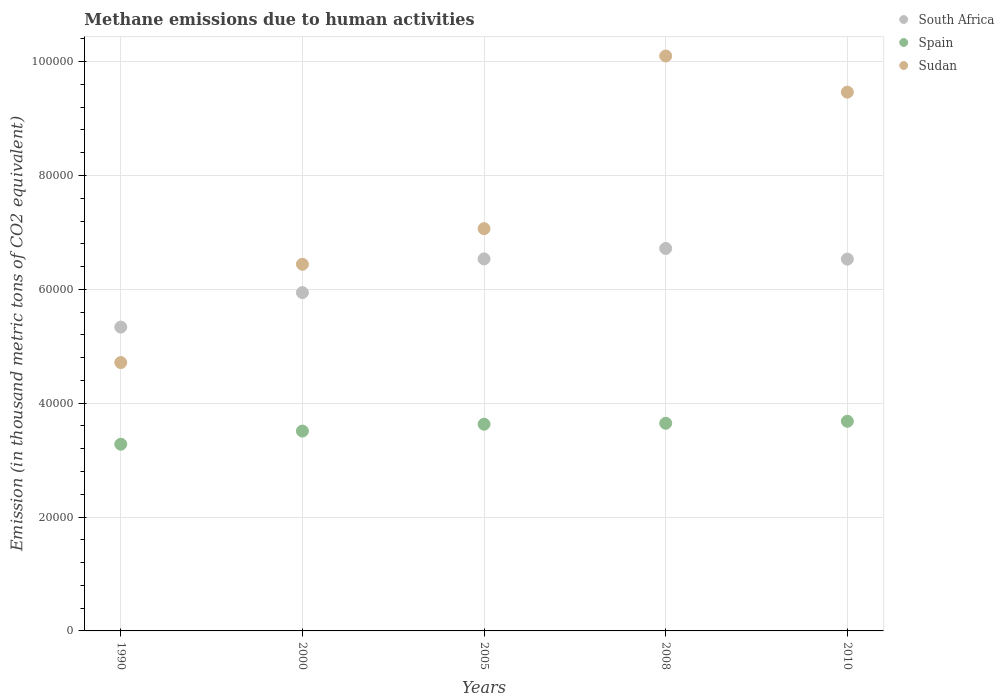What is the amount of methane emitted in Sudan in 1990?
Provide a short and direct response. 4.71e+04. Across all years, what is the maximum amount of methane emitted in Sudan?
Your response must be concise. 1.01e+05. Across all years, what is the minimum amount of methane emitted in Sudan?
Make the answer very short. 4.71e+04. What is the total amount of methane emitted in South Africa in the graph?
Make the answer very short. 3.11e+05. What is the difference between the amount of methane emitted in South Africa in 1990 and that in 2000?
Make the answer very short. -6061.3. What is the difference between the amount of methane emitted in Spain in 2005 and the amount of methane emitted in South Africa in 2008?
Provide a succinct answer. -3.09e+04. What is the average amount of methane emitted in Spain per year?
Offer a terse response. 3.55e+04. In the year 2005, what is the difference between the amount of methane emitted in Spain and amount of methane emitted in Sudan?
Provide a succinct answer. -3.43e+04. What is the ratio of the amount of methane emitted in South Africa in 2005 to that in 2008?
Keep it short and to the point. 0.97. Is the amount of methane emitted in Sudan in 2000 less than that in 2010?
Give a very brief answer. Yes. What is the difference between the highest and the second highest amount of methane emitted in Sudan?
Your answer should be compact. 6353.9. What is the difference between the highest and the lowest amount of methane emitted in Sudan?
Your answer should be compact. 5.39e+04. Is the sum of the amount of methane emitted in Sudan in 1990 and 2000 greater than the maximum amount of methane emitted in Spain across all years?
Your answer should be very brief. Yes. Does the amount of methane emitted in Spain monotonically increase over the years?
Provide a short and direct response. Yes. How many dotlines are there?
Offer a very short reply. 3. How many years are there in the graph?
Your response must be concise. 5. Does the graph contain grids?
Give a very brief answer. Yes. Where does the legend appear in the graph?
Provide a succinct answer. Top right. What is the title of the graph?
Ensure brevity in your answer.  Methane emissions due to human activities. Does "Hungary" appear as one of the legend labels in the graph?
Provide a short and direct response. No. What is the label or title of the X-axis?
Your answer should be very brief. Years. What is the label or title of the Y-axis?
Your answer should be compact. Emission (in thousand metric tons of CO2 equivalent). What is the Emission (in thousand metric tons of CO2 equivalent) in South Africa in 1990?
Your response must be concise. 5.34e+04. What is the Emission (in thousand metric tons of CO2 equivalent) in Spain in 1990?
Offer a terse response. 3.28e+04. What is the Emission (in thousand metric tons of CO2 equivalent) of Sudan in 1990?
Offer a very short reply. 4.71e+04. What is the Emission (in thousand metric tons of CO2 equivalent) of South Africa in 2000?
Offer a very short reply. 5.94e+04. What is the Emission (in thousand metric tons of CO2 equivalent) of Spain in 2000?
Provide a short and direct response. 3.51e+04. What is the Emission (in thousand metric tons of CO2 equivalent) in Sudan in 2000?
Offer a terse response. 6.44e+04. What is the Emission (in thousand metric tons of CO2 equivalent) of South Africa in 2005?
Make the answer very short. 6.53e+04. What is the Emission (in thousand metric tons of CO2 equivalent) in Spain in 2005?
Keep it short and to the point. 3.63e+04. What is the Emission (in thousand metric tons of CO2 equivalent) in Sudan in 2005?
Give a very brief answer. 7.07e+04. What is the Emission (in thousand metric tons of CO2 equivalent) in South Africa in 2008?
Keep it short and to the point. 6.72e+04. What is the Emission (in thousand metric tons of CO2 equivalent) in Spain in 2008?
Give a very brief answer. 3.65e+04. What is the Emission (in thousand metric tons of CO2 equivalent) of Sudan in 2008?
Your answer should be compact. 1.01e+05. What is the Emission (in thousand metric tons of CO2 equivalent) of South Africa in 2010?
Your response must be concise. 6.53e+04. What is the Emission (in thousand metric tons of CO2 equivalent) of Spain in 2010?
Provide a short and direct response. 3.68e+04. What is the Emission (in thousand metric tons of CO2 equivalent) of Sudan in 2010?
Provide a succinct answer. 9.46e+04. Across all years, what is the maximum Emission (in thousand metric tons of CO2 equivalent) in South Africa?
Your answer should be very brief. 6.72e+04. Across all years, what is the maximum Emission (in thousand metric tons of CO2 equivalent) in Spain?
Your answer should be compact. 3.68e+04. Across all years, what is the maximum Emission (in thousand metric tons of CO2 equivalent) of Sudan?
Offer a terse response. 1.01e+05. Across all years, what is the minimum Emission (in thousand metric tons of CO2 equivalent) in South Africa?
Offer a very short reply. 5.34e+04. Across all years, what is the minimum Emission (in thousand metric tons of CO2 equivalent) in Spain?
Offer a terse response. 3.28e+04. Across all years, what is the minimum Emission (in thousand metric tons of CO2 equivalent) of Sudan?
Your answer should be compact. 4.71e+04. What is the total Emission (in thousand metric tons of CO2 equivalent) of South Africa in the graph?
Make the answer very short. 3.11e+05. What is the total Emission (in thousand metric tons of CO2 equivalent) of Spain in the graph?
Keep it short and to the point. 1.78e+05. What is the total Emission (in thousand metric tons of CO2 equivalent) in Sudan in the graph?
Your response must be concise. 3.78e+05. What is the difference between the Emission (in thousand metric tons of CO2 equivalent) of South Africa in 1990 and that in 2000?
Your answer should be very brief. -6061.3. What is the difference between the Emission (in thousand metric tons of CO2 equivalent) of Spain in 1990 and that in 2000?
Provide a short and direct response. -2310.4. What is the difference between the Emission (in thousand metric tons of CO2 equivalent) of Sudan in 1990 and that in 2000?
Offer a very short reply. -1.73e+04. What is the difference between the Emission (in thousand metric tons of CO2 equivalent) of South Africa in 1990 and that in 2005?
Offer a very short reply. -1.20e+04. What is the difference between the Emission (in thousand metric tons of CO2 equivalent) in Spain in 1990 and that in 2005?
Your response must be concise. -3519.1. What is the difference between the Emission (in thousand metric tons of CO2 equivalent) of Sudan in 1990 and that in 2005?
Offer a very short reply. -2.35e+04. What is the difference between the Emission (in thousand metric tons of CO2 equivalent) in South Africa in 1990 and that in 2008?
Your answer should be very brief. -1.38e+04. What is the difference between the Emission (in thousand metric tons of CO2 equivalent) of Spain in 1990 and that in 2008?
Provide a short and direct response. -3681.4. What is the difference between the Emission (in thousand metric tons of CO2 equivalent) of Sudan in 1990 and that in 2008?
Keep it short and to the point. -5.39e+04. What is the difference between the Emission (in thousand metric tons of CO2 equivalent) of South Africa in 1990 and that in 2010?
Your response must be concise. -1.19e+04. What is the difference between the Emission (in thousand metric tons of CO2 equivalent) in Spain in 1990 and that in 2010?
Ensure brevity in your answer.  -4029.1. What is the difference between the Emission (in thousand metric tons of CO2 equivalent) of Sudan in 1990 and that in 2010?
Your response must be concise. -4.75e+04. What is the difference between the Emission (in thousand metric tons of CO2 equivalent) in South Africa in 2000 and that in 2005?
Keep it short and to the point. -5917.5. What is the difference between the Emission (in thousand metric tons of CO2 equivalent) in Spain in 2000 and that in 2005?
Your answer should be compact. -1208.7. What is the difference between the Emission (in thousand metric tons of CO2 equivalent) in Sudan in 2000 and that in 2005?
Ensure brevity in your answer.  -6254.5. What is the difference between the Emission (in thousand metric tons of CO2 equivalent) of South Africa in 2000 and that in 2008?
Your answer should be very brief. -7757.2. What is the difference between the Emission (in thousand metric tons of CO2 equivalent) in Spain in 2000 and that in 2008?
Offer a terse response. -1371. What is the difference between the Emission (in thousand metric tons of CO2 equivalent) of Sudan in 2000 and that in 2008?
Keep it short and to the point. -3.66e+04. What is the difference between the Emission (in thousand metric tons of CO2 equivalent) in South Africa in 2000 and that in 2010?
Provide a succinct answer. -5881.2. What is the difference between the Emission (in thousand metric tons of CO2 equivalent) in Spain in 2000 and that in 2010?
Your response must be concise. -1718.7. What is the difference between the Emission (in thousand metric tons of CO2 equivalent) in Sudan in 2000 and that in 2010?
Provide a short and direct response. -3.02e+04. What is the difference between the Emission (in thousand metric tons of CO2 equivalent) of South Africa in 2005 and that in 2008?
Ensure brevity in your answer.  -1839.7. What is the difference between the Emission (in thousand metric tons of CO2 equivalent) in Spain in 2005 and that in 2008?
Provide a short and direct response. -162.3. What is the difference between the Emission (in thousand metric tons of CO2 equivalent) of Sudan in 2005 and that in 2008?
Make the answer very short. -3.03e+04. What is the difference between the Emission (in thousand metric tons of CO2 equivalent) in South Africa in 2005 and that in 2010?
Your answer should be compact. 36.3. What is the difference between the Emission (in thousand metric tons of CO2 equivalent) of Spain in 2005 and that in 2010?
Ensure brevity in your answer.  -510. What is the difference between the Emission (in thousand metric tons of CO2 equivalent) in Sudan in 2005 and that in 2010?
Your answer should be compact. -2.40e+04. What is the difference between the Emission (in thousand metric tons of CO2 equivalent) in South Africa in 2008 and that in 2010?
Ensure brevity in your answer.  1876. What is the difference between the Emission (in thousand metric tons of CO2 equivalent) in Spain in 2008 and that in 2010?
Make the answer very short. -347.7. What is the difference between the Emission (in thousand metric tons of CO2 equivalent) in Sudan in 2008 and that in 2010?
Give a very brief answer. 6353.9. What is the difference between the Emission (in thousand metric tons of CO2 equivalent) of South Africa in 1990 and the Emission (in thousand metric tons of CO2 equivalent) of Spain in 2000?
Offer a terse response. 1.83e+04. What is the difference between the Emission (in thousand metric tons of CO2 equivalent) of South Africa in 1990 and the Emission (in thousand metric tons of CO2 equivalent) of Sudan in 2000?
Offer a very short reply. -1.10e+04. What is the difference between the Emission (in thousand metric tons of CO2 equivalent) in Spain in 1990 and the Emission (in thousand metric tons of CO2 equivalent) in Sudan in 2000?
Your response must be concise. -3.16e+04. What is the difference between the Emission (in thousand metric tons of CO2 equivalent) in South Africa in 1990 and the Emission (in thousand metric tons of CO2 equivalent) in Spain in 2005?
Your response must be concise. 1.71e+04. What is the difference between the Emission (in thousand metric tons of CO2 equivalent) in South Africa in 1990 and the Emission (in thousand metric tons of CO2 equivalent) in Sudan in 2005?
Ensure brevity in your answer.  -1.73e+04. What is the difference between the Emission (in thousand metric tons of CO2 equivalent) in Spain in 1990 and the Emission (in thousand metric tons of CO2 equivalent) in Sudan in 2005?
Provide a succinct answer. -3.79e+04. What is the difference between the Emission (in thousand metric tons of CO2 equivalent) of South Africa in 1990 and the Emission (in thousand metric tons of CO2 equivalent) of Spain in 2008?
Make the answer very short. 1.69e+04. What is the difference between the Emission (in thousand metric tons of CO2 equivalent) in South Africa in 1990 and the Emission (in thousand metric tons of CO2 equivalent) in Sudan in 2008?
Offer a very short reply. -4.76e+04. What is the difference between the Emission (in thousand metric tons of CO2 equivalent) of Spain in 1990 and the Emission (in thousand metric tons of CO2 equivalent) of Sudan in 2008?
Your answer should be compact. -6.82e+04. What is the difference between the Emission (in thousand metric tons of CO2 equivalent) of South Africa in 1990 and the Emission (in thousand metric tons of CO2 equivalent) of Spain in 2010?
Your answer should be very brief. 1.65e+04. What is the difference between the Emission (in thousand metric tons of CO2 equivalent) in South Africa in 1990 and the Emission (in thousand metric tons of CO2 equivalent) in Sudan in 2010?
Offer a terse response. -4.13e+04. What is the difference between the Emission (in thousand metric tons of CO2 equivalent) in Spain in 1990 and the Emission (in thousand metric tons of CO2 equivalent) in Sudan in 2010?
Provide a short and direct response. -6.18e+04. What is the difference between the Emission (in thousand metric tons of CO2 equivalent) of South Africa in 2000 and the Emission (in thousand metric tons of CO2 equivalent) of Spain in 2005?
Ensure brevity in your answer.  2.31e+04. What is the difference between the Emission (in thousand metric tons of CO2 equivalent) in South Africa in 2000 and the Emission (in thousand metric tons of CO2 equivalent) in Sudan in 2005?
Offer a very short reply. -1.12e+04. What is the difference between the Emission (in thousand metric tons of CO2 equivalent) in Spain in 2000 and the Emission (in thousand metric tons of CO2 equivalent) in Sudan in 2005?
Your answer should be compact. -3.56e+04. What is the difference between the Emission (in thousand metric tons of CO2 equivalent) in South Africa in 2000 and the Emission (in thousand metric tons of CO2 equivalent) in Spain in 2008?
Ensure brevity in your answer.  2.30e+04. What is the difference between the Emission (in thousand metric tons of CO2 equivalent) of South Africa in 2000 and the Emission (in thousand metric tons of CO2 equivalent) of Sudan in 2008?
Provide a succinct answer. -4.16e+04. What is the difference between the Emission (in thousand metric tons of CO2 equivalent) of Spain in 2000 and the Emission (in thousand metric tons of CO2 equivalent) of Sudan in 2008?
Keep it short and to the point. -6.59e+04. What is the difference between the Emission (in thousand metric tons of CO2 equivalent) in South Africa in 2000 and the Emission (in thousand metric tons of CO2 equivalent) in Spain in 2010?
Make the answer very short. 2.26e+04. What is the difference between the Emission (in thousand metric tons of CO2 equivalent) of South Africa in 2000 and the Emission (in thousand metric tons of CO2 equivalent) of Sudan in 2010?
Keep it short and to the point. -3.52e+04. What is the difference between the Emission (in thousand metric tons of CO2 equivalent) in Spain in 2000 and the Emission (in thousand metric tons of CO2 equivalent) in Sudan in 2010?
Your response must be concise. -5.95e+04. What is the difference between the Emission (in thousand metric tons of CO2 equivalent) of South Africa in 2005 and the Emission (in thousand metric tons of CO2 equivalent) of Spain in 2008?
Your answer should be very brief. 2.89e+04. What is the difference between the Emission (in thousand metric tons of CO2 equivalent) in South Africa in 2005 and the Emission (in thousand metric tons of CO2 equivalent) in Sudan in 2008?
Ensure brevity in your answer.  -3.56e+04. What is the difference between the Emission (in thousand metric tons of CO2 equivalent) of Spain in 2005 and the Emission (in thousand metric tons of CO2 equivalent) of Sudan in 2008?
Offer a very short reply. -6.47e+04. What is the difference between the Emission (in thousand metric tons of CO2 equivalent) in South Africa in 2005 and the Emission (in thousand metric tons of CO2 equivalent) in Spain in 2010?
Provide a succinct answer. 2.85e+04. What is the difference between the Emission (in thousand metric tons of CO2 equivalent) in South Africa in 2005 and the Emission (in thousand metric tons of CO2 equivalent) in Sudan in 2010?
Give a very brief answer. -2.93e+04. What is the difference between the Emission (in thousand metric tons of CO2 equivalent) of Spain in 2005 and the Emission (in thousand metric tons of CO2 equivalent) of Sudan in 2010?
Provide a short and direct response. -5.83e+04. What is the difference between the Emission (in thousand metric tons of CO2 equivalent) in South Africa in 2008 and the Emission (in thousand metric tons of CO2 equivalent) in Spain in 2010?
Provide a succinct answer. 3.04e+04. What is the difference between the Emission (in thousand metric tons of CO2 equivalent) of South Africa in 2008 and the Emission (in thousand metric tons of CO2 equivalent) of Sudan in 2010?
Your answer should be compact. -2.75e+04. What is the difference between the Emission (in thousand metric tons of CO2 equivalent) of Spain in 2008 and the Emission (in thousand metric tons of CO2 equivalent) of Sudan in 2010?
Ensure brevity in your answer.  -5.82e+04. What is the average Emission (in thousand metric tons of CO2 equivalent) in South Africa per year?
Your response must be concise. 6.21e+04. What is the average Emission (in thousand metric tons of CO2 equivalent) in Spain per year?
Offer a very short reply. 3.55e+04. What is the average Emission (in thousand metric tons of CO2 equivalent) in Sudan per year?
Your answer should be compact. 7.56e+04. In the year 1990, what is the difference between the Emission (in thousand metric tons of CO2 equivalent) in South Africa and Emission (in thousand metric tons of CO2 equivalent) in Spain?
Your response must be concise. 2.06e+04. In the year 1990, what is the difference between the Emission (in thousand metric tons of CO2 equivalent) in South Africa and Emission (in thousand metric tons of CO2 equivalent) in Sudan?
Make the answer very short. 6227.2. In the year 1990, what is the difference between the Emission (in thousand metric tons of CO2 equivalent) in Spain and Emission (in thousand metric tons of CO2 equivalent) in Sudan?
Keep it short and to the point. -1.43e+04. In the year 2000, what is the difference between the Emission (in thousand metric tons of CO2 equivalent) of South Africa and Emission (in thousand metric tons of CO2 equivalent) of Spain?
Give a very brief answer. 2.43e+04. In the year 2000, what is the difference between the Emission (in thousand metric tons of CO2 equivalent) in South Africa and Emission (in thousand metric tons of CO2 equivalent) in Sudan?
Your answer should be compact. -4976.8. In the year 2000, what is the difference between the Emission (in thousand metric tons of CO2 equivalent) of Spain and Emission (in thousand metric tons of CO2 equivalent) of Sudan?
Provide a short and direct response. -2.93e+04. In the year 2005, what is the difference between the Emission (in thousand metric tons of CO2 equivalent) of South Africa and Emission (in thousand metric tons of CO2 equivalent) of Spain?
Your response must be concise. 2.90e+04. In the year 2005, what is the difference between the Emission (in thousand metric tons of CO2 equivalent) of South Africa and Emission (in thousand metric tons of CO2 equivalent) of Sudan?
Your response must be concise. -5313.8. In the year 2005, what is the difference between the Emission (in thousand metric tons of CO2 equivalent) of Spain and Emission (in thousand metric tons of CO2 equivalent) of Sudan?
Ensure brevity in your answer.  -3.43e+04. In the year 2008, what is the difference between the Emission (in thousand metric tons of CO2 equivalent) of South Africa and Emission (in thousand metric tons of CO2 equivalent) of Spain?
Your response must be concise. 3.07e+04. In the year 2008, what is the difference between the Emission (in thousand metric tons of CO2 equivalent) in South Africa and Emission (in thousand metric tons of CO2 equivalent) in Sudan?
Offer a terse response. -3.38e+04. In the year 2008, what is the difference between the Emission (in thousand metric tons of CO2 equivalent) in Spain and Emission (in thousand metric tons of CO2 equivalent) in Sudan?
Give a very brief answer. -6.45e+04. In the year 2010, what is the difference between the Emission (in thousand metric tons of CO2 equivalent) in South Africa and Emission (in thousand metric tons of CO2 equivalent) in Spain?
Make the answer very short. 2.85e+04. In the year 2010, what is the difference between the Emission (in thousand metric tons of CO2 equivalent) in South Africa and Emission (in thousand metric tons of CO2 equivalent) in Sudan?
Ensure brevity in your answer.  -2.93e+04. In the year 2010, what is the difference between the Emission (in thousand metric tons of CO2 equivalent) in Spain and Emission (in thousand metric tons of CO2 equivalent) in Sudan?
Your answer should be compact. -5.78e+04. What is the ratio of the Emission (in thousand metric tons of CO2 equivalent) in South Africa in 1990 to that in 2000?
Make the answer very short. 0.9. What is the ratio of the Emission (in thousand metric tons of CO2 equivalent) of Spain in 1990 to that in 2000?
Provide a succinct answer. 0.93. What is the ratio of the Emission (in thousand metric tons of CO2 equivalent) in Sudan in 1990 to that in 2000?
Give a very brief answer. 0.73. What is the ratio of the Emission (in thousand metric tons of CO2 equivalent) in South Africa in 1990 to that in 2005?
Your answer should be compact. 0.82. What is the ratio of the Emission (in thousand metric tons of CO2 equivalent) in Spain in 1990 to that in 2005?
Offer a terse response. 0.9. What is the ratio of the Emission (in thousand metric tons of CO2 equivalent) in Sudan in 1990 to that in 2005?
Give a very brief answer. 0.67. What is the ratio of the Emission (in thousand metric tons of CO2 equivalent) of South Africa in 1990 to that in 2008?
Your answer should be very brief. 0.79. What is the ratio of the Emission (in thousand metric tons of CO2 equivalent) of Spain in 1990 to that in 2008?
Your response must be concise. 0.9. What is the ratio of the Emission (in thousand metric tons of CO2 equivalent) in Sudan in 1990 to that in 2008?
Give a very brief answer. 0.47. What is the ratio of the Emission (in thousand metric tons of CO2 equivalent) in South Africa in 1990 to that in 2010?
Provide a short and direct response. 0.82. What is the ratio of the Emission (in thousand metric tons of CO2 equivalent) of Spain in 1990 to that in 2010?
Make the answer very short. 0.89. What is the ratio of the Emission (in thousand metric tons of CO2 equivalent) of Sudan in 1990 to that in 2010?
Provide a succinct answer. 0.5. What is the ratio of the Emission (in thousand metric tons of CO2 equivalent) of South Africa in 2000 to that in 2005?
Ensure brevity in your answer.  0.91. What is the ratio of the Emission (in thousand metric tons of CO2 equivalent) in Spain in 2000 to that in 2005?
Provide a short and direct response. 0.97. What is the ratio of the Emission (in thousand metric tons of CO2 equivalent) of Sudan in 2000 to that in 2005?
Your response must be concise. 0.91. What is the ratio of the Emission (in thousand metric tons of CO2 equivalent) in South Africa in 2000 to that in 2008?
Provide a succinct answer. 0.88. What is the ratio of the Emission (in thousand metric tons of CO2 equivalent) in Spain in 2000 to that in 2008?
Offer a very short reply. 0.96. What is the ratio of the Emission (in thousand metric tons of CO2 equivalent) in Sudan in 2000 to that in 2008?
Offer a very short reply. 0.64. What is the ratio of the Emission (in thousand metric tons of CO2 equivalent) in South Africa in 2000 to that in 2010?
Offer a very short reply. 0.91. What is the ratio of the Emission (in thousand metric tons of CO2 equivalent) of Spain in 2000 to that in 2010?
Provide a short and direct response. 0.95. What is the ratio of the Emission (in thousand metric tons of CO2 equivalent) of Sudan in 2000 to that in 2010?
Your answer should be very brief. 0.68. What is the ratio of the Emission (in thousand metric tons of CO2 equivalent) of South Africa in 2005 to that in 2008?
Your response must be concise. 0.97. What is the ratio of the Emission (in thousand metric tons of CO2 equivalent) of Sudan in 2005 to that in 2008?
Ensure brevity in your answer.  0.7. What is the ratio of the Emission (in thousand metric tons of CO2 equivalent) in South Africa in 2005 to that in 2010?
Make the answer very short. 1. What is the ratio of the Emission (in thousand metric tons of CO2 equivalent) in Spain in 2005 to that in 2010?
Offer a very short reply. 0.99. What is the ratio of the Emission (in thousand metric tons of CO2 equivalent) of Sudan in 2005 to that in 2010?
Keep it short and to the point. 0.75. What is the ratio of the Emission (in thousand metric tons of CO2 equivalent) in South Africa in 2008 to that in 2010?
Offer a terse response. 1.03. What is the ratio of the Emission (in thousand metric tons of CO2 equivalent) of Spain in 2008 to that in 2010?
Offer a very short reply. 0.99. What is the ratio of the Emission (in thousand metric tons of CO2 equivalent) of Sudan in 2008 to that in 2010?
Provide a succinct answer. 1.07. What is the difference between the highest and the second highest Emission (in thousand metric tons of CO2 equivalent) of South Africa?
Keep it short and to the point. 1839.7. What is the difference between the highest and the second highest Emission (in thousand metric tons of CO2 equivalent) of Spain?
Offer a very short reply. 347.7. What is the difference between the highest and the second highest Emission (in thousand metric tons of CO2 equivalent) of Sudan?
Your response must be concise. 6353.9. What is the difference between the highest and the lowest Emission (in thousand metric tons of CO2 equivalent) in South Africa?
Offer a terse response. 1.38e+04. What is the difference between the highest and the lowest Emission (in thousand metric tons of CO2 equivalent) in Spain?
Provide a short and direct response. 4029.1. What is the difference between the highest and the lowest Emission (in thousand metric tons of CO2 equivalent) of Sudan?
Keep it short and to the point. 5.39e+04. 